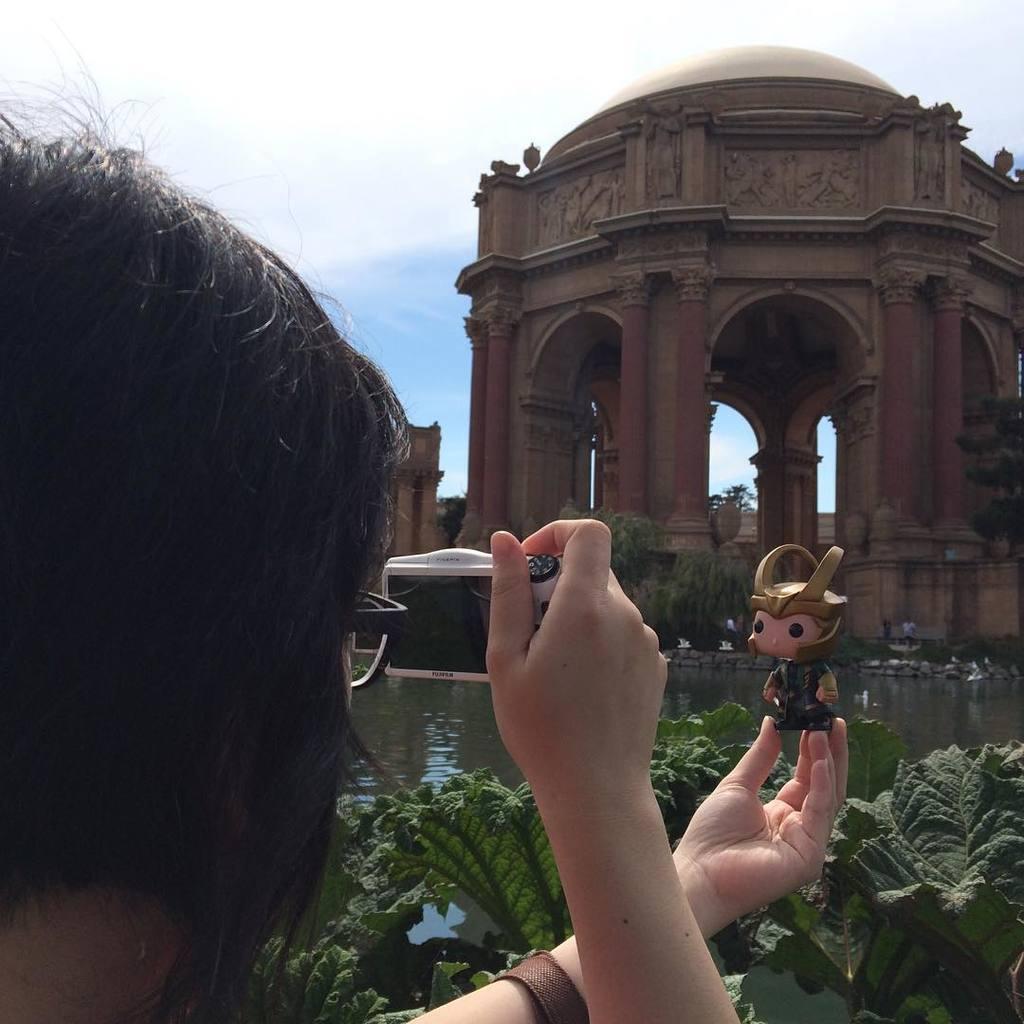How would you summarize this image in a sentence or two? In this image I can see a person wearing spectacles is holding a camera which is white in color in her hand and a toy in her other hand. In the background I can see few trees, some water, few other persons, few buildings and the sky. 